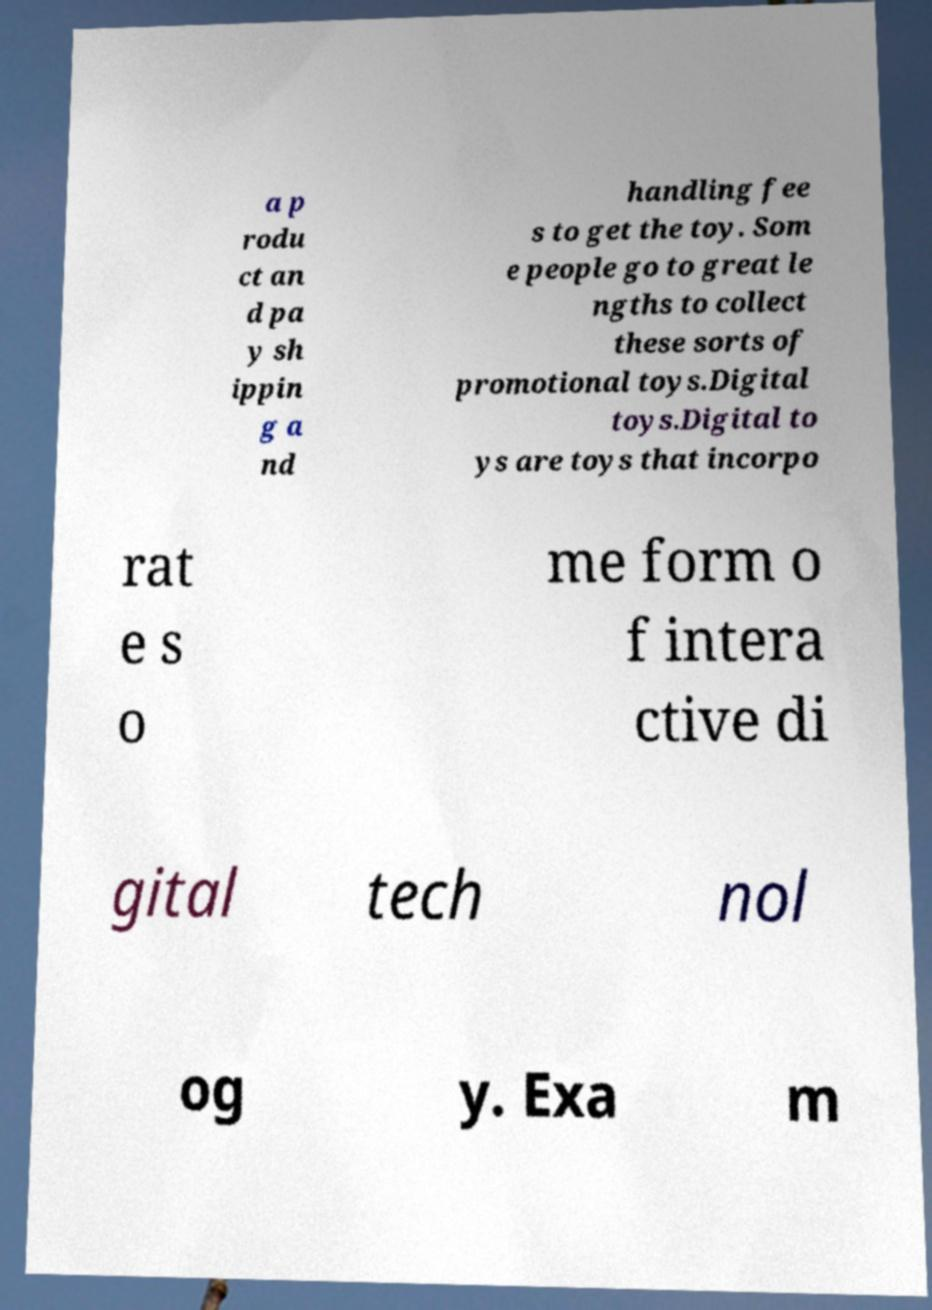Can you read and provide the text displayed in the image?This photo seems to have some interesting text. Can you extract and type it out for me? a p rodu ct an d pa y sh ippin g a nd handling fee s to get the toy. Som e people go to great le ngths to collect these sorts of promotional toys.Digital toys.Digital to ys are toys that incorpo rat e s o me form o f intera ctive di gital tech nol og y. Exa m 